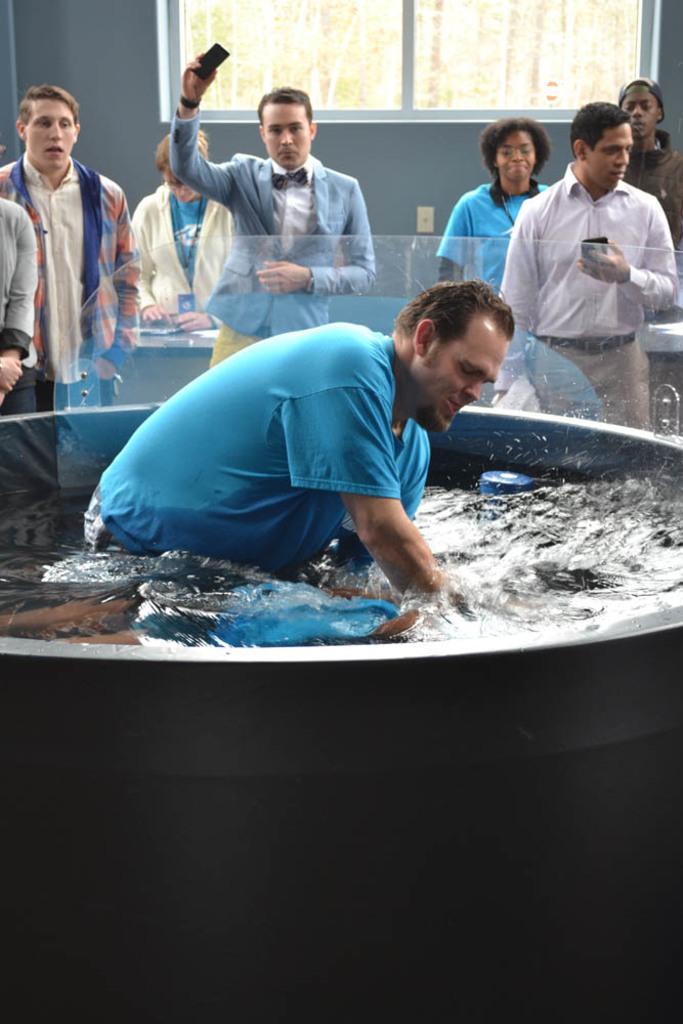Can you describe this image briefly? Here in the middle we can see a person in a tub which is filled with water over there and behind him we can see number of people standing over there and behind them we can see a window present, through which we can see trees which are present outside over there. 